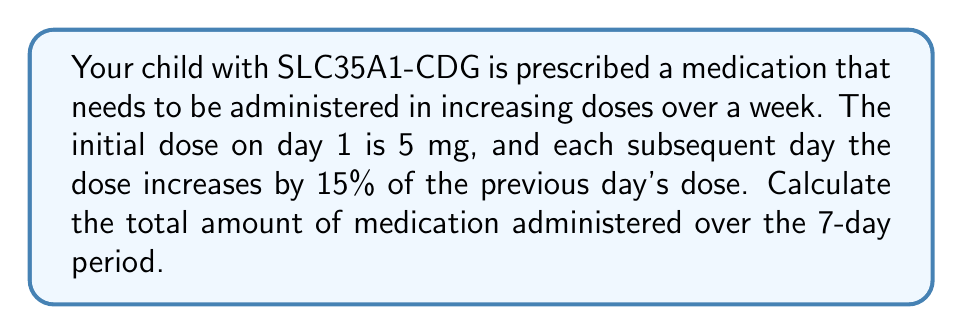Show me your answer to this math problem. Let's approach this step-by-step:

1) First, we need to calculate the dose for each day:

   Day 1: 5 mg
   Day 2: $5 * (1 + 0.15) = 5 * 1.15 = 5.75$ mg
   Day 3: $5.75 * 1.15 = 6.6125$ mg
   Day 4: $6.6125 * 1.15 = 7.604375$ mg
   Day 5: $7.604375 * 1.15 = 8.74503125$ mg
   Day 6: $8.74503125 * 1.15 = 10.0567859375$ mg
   Day 7: $10.0567859375 * 1.15 = 11.565303828125$ mg

2) Now, we need to sum up all these doses:

   $$\text{Total} = 5 + 5.75 + 6.6125 + 7.604375 + 8.74503125 + 10.0567859375 + 11.565303828125$$

3) Using a calculator or computer to sum these numbers:

   $$\text{Total} = 55.32900390625 \text{ mg}$$

4) Rounding to two decimal places for practical use:

   $$\text{Total} \approx 55.33 \text{ mg}$$

This problem is an example of a geometric sequence with a common ratio of 1.15 (representing the 15% increase each day). The sum of this geometric sequence over 7 terms gives us the total amount of medication administered.
Answer: The total amount of medication administered over the 7-day period is approximately 55.33 mg. 